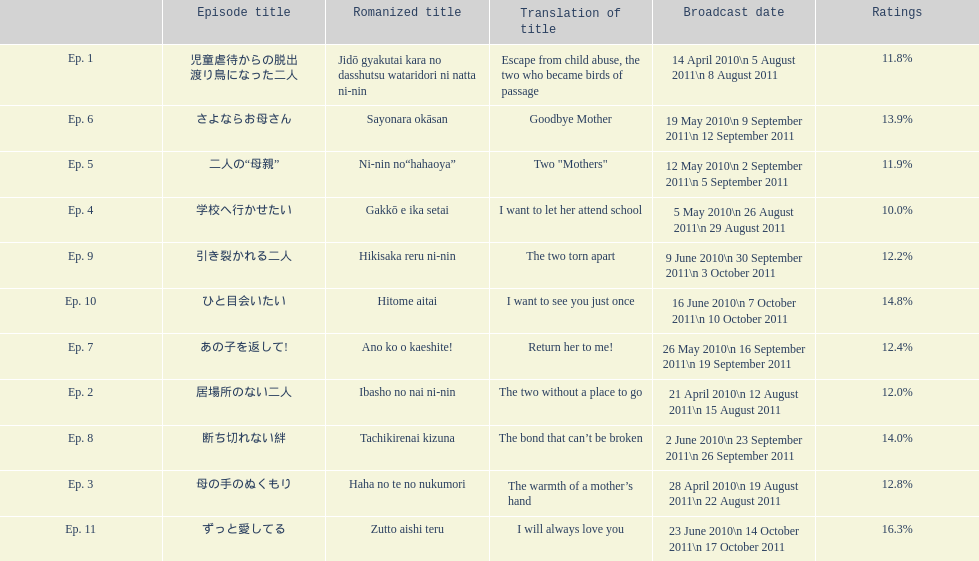What was the top rated episode of this show? ずっと愛してる. 